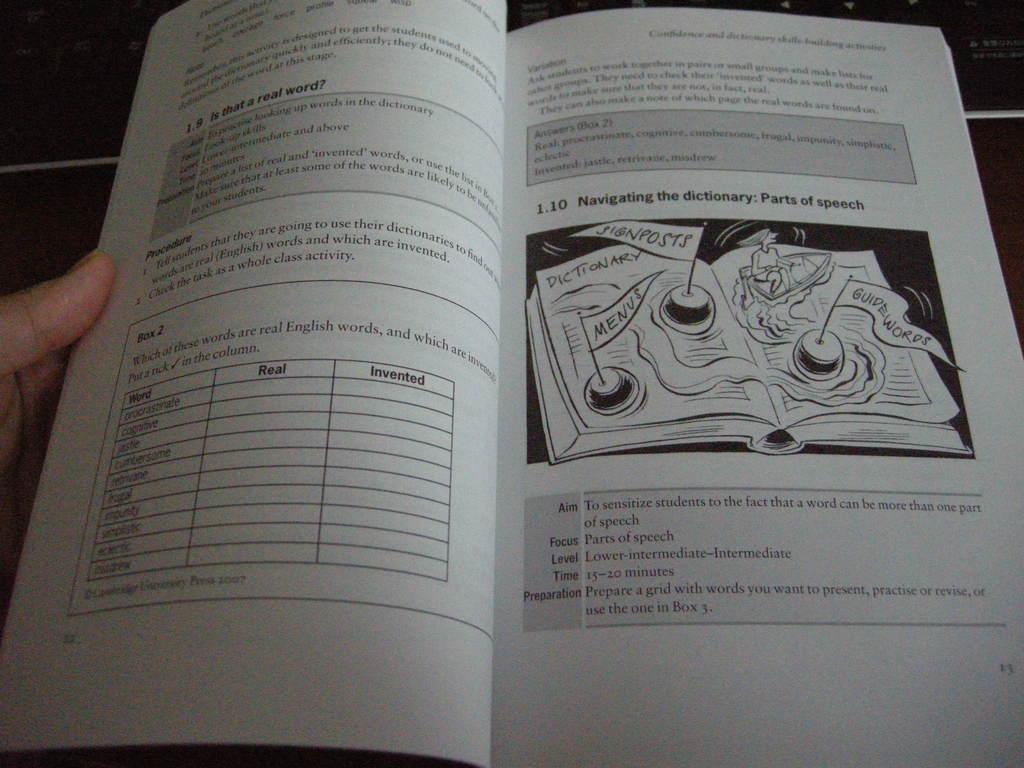What do the two columns say?
Make the answer very short. Real invented. What is the title of section 1.9?
Provide a succinct answer. Is that a real word?. 